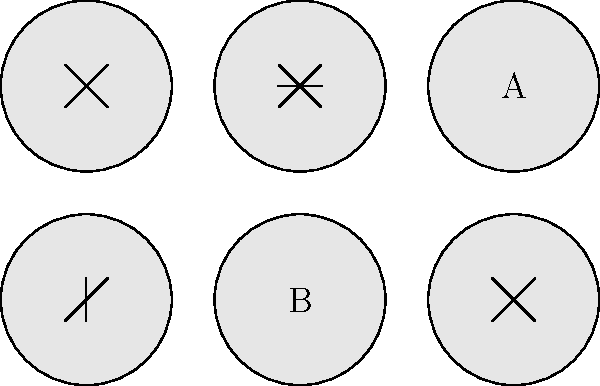Match the UI icons to their corresponding functions:

1. Close or exit
2. Minimize
3. Options or menu
4. Maximize or fullscreen To match the UI icons to their corresponding functions, let's analyze each icon:

1. The icon at (0,0) shows an "X" shape. This is a universally recognized symbol for closing or exiting an application or window.

2. The icon at (50,0) displays three horizontal lines. This is commonly used to represent a menu or options, allowing users to access additional features or settings.

3. The icon at (100,0) shows the letter "A". This doesn't correspond to any of the given functions and is likely used for a different purpose, such as text formatting.

4. The icon at (0,-50) shows a single horizontal line at the bottom. This typically represents the minimize function, which reduces the window to the taskbar.

5. The icon at (50,-50) displays the letter "B". Similar to the "A" icon, this doesn't match any of the given functions.

6. The icon at (100,-50) shows two overlapping squares. This commonly represents the maximize or fullscreen function, allowing users to expand the window to fill the entire screen.

Based on this analysis, we can match the icons to their functions as follows:
- Close or exit: (0,0)
- Options or menu: (50,0)
- Minimize: (0,-50)
- Maximize or fullscreen: (100,-50)
Answer: Close: (0,0), Menu: (50,0), Minimize: (0,-50), Maximize: (100,-50) 